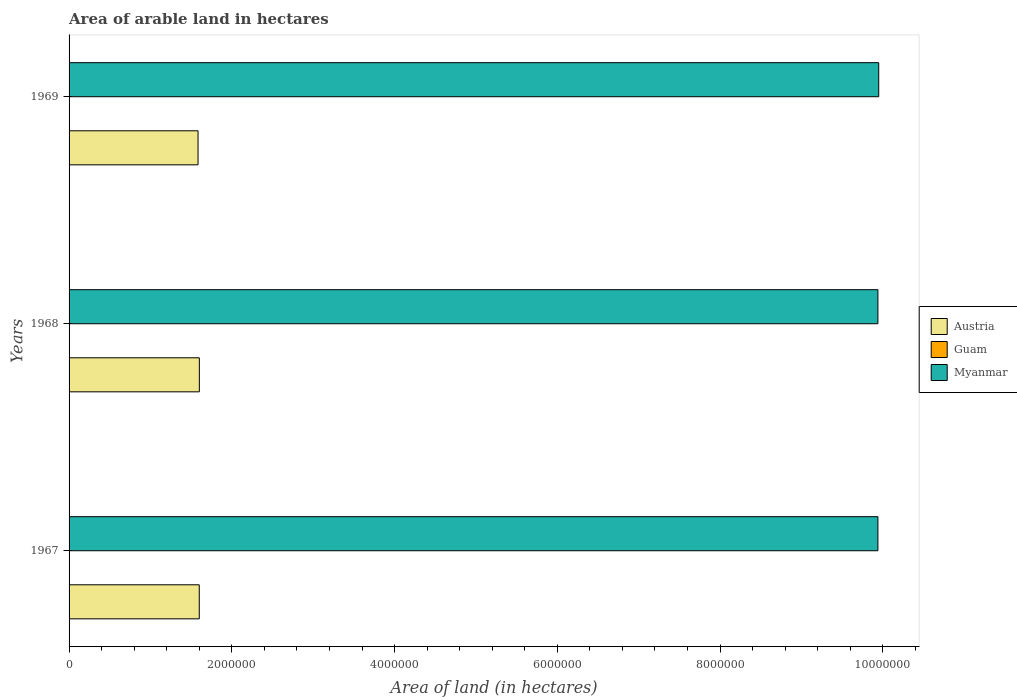How many different coloured bars are there?
Offer a very short reply. 3. How many groups of bars are there?
Give a very brief answer. 3. Are the number of bars per tick equal to the number of legend labels?
Keep it short and to the point. Yes. What is the label of the 3rd group of bars from the top?
Make the answer very short. 1967. What is the total arable land in Myanmar in 1968?
Offer a very short reply. 9.94e+06. Across all years, what is the maximum total arable land in Myanmar?
Offer a terse response. 9.95e+06. Across all years, what is the minimum total arable land in Myanmar?
Ensure brevity in your answer.  9.94e+06. In which year was the total arable land in Austria maximum?
Ensure brevity in your answer.  1968. In which year was the total arable land in Myanmar minimum?
Make the answer very short. 1967. What is the total total arable land in Guam in the graph?
Your answer should be compact. 6000. What is the difference between the total arable land in Guam in 1967 and that in 1968?
Provide a succinct answer. 0. What is the difference between the total arable land in Myanmar in 1967 and the total arable land in Austria in 1969?
Your answer should be very brief. 8.36e+06. What is the average total arable land in Myanmar per year?
Your response must be concise. 9.94e+06. In the year 1967, what is the difference between the total arable land in Myanmar and total arable land in Guam?
Offer a very short reply. 9.94e+06. In how many years, is the total arable land in Myanmar greater than 400000 hectares?
Keep it short and to the point. 3. Is the total arable land in Guam in 1968 less than that in 1969?
Provide a short and direct response. No. What is the difference between the highest and the second highest total arable land in Austria?
Give a very brief answer. 1000. What is the difference between the highest and the lowest total arable land in Myanmar?
Make the answer very short. 10000. In how many years, is the total arable land in Austria greater than the average total arable land in Austria taken over all years?
Give a very brief answer. 2. What does the 2nd bar from the top in 1968 represents?
Your response must be concise. Guam. What does the 1st bar from the bottom in 1967 represents?
Make the answer very short. Austria. Are all the bars in the graph horizontal?
Make the answer very short. Yes. Are the values on the major ticks of X-axis written in scientific E-notation?
Keep it short and to the point. No. How are the legend labels stacked?
Give a very brief answer. Vertical. What is the title of the graph?
Provide a short and direct response. Area of arable land in hectares. What is the label or title of the X-axis?
Your response must be concise. Area of land (in hectares). What is the label or title of the Y-axis?
Ensure brevity in your answer.  Years. What is the Area of land (in hectares) in Austria in 1967?
Ensure brevity in your answer.  1.60e+06. What is the Area of land (in hectares) in Myanmar in 1967?
Offer a very short reply. 9.94e+06. What is the Area of land (in hectares) in Austria in 1968?
Offer a terse response. 1.60e+06. What is the Area of land (in hectares) of Guam in 1968?
Provide a short and direct response. 2000. What is the Area of land (in hectares) in Myanmar in 1968?
Ensure brevity in your answer.  9.94e+06. What is the Area of land (in hectares) of Austria in 1969?
Make the answer very short. 1.58e+06. What is the Area of land (in hectares) of Myanmar in 1969?
Offer a terse response. 9.95e+06. Across all years, what is the maximum Area of land (in hectares) of Austria?
Ensure brevity in your answer.  1.60e+06. Across all years, what is the maximum Area of land (in hectares) in Guam?
Offer a very short reply. 2000. Across all years, what is the maximum Area of land (in hectares) in Myanmar?
Offer a very short reply. 9.95e+06. Across all years, what is the minimum Area of land (in hectares) in Austria?
Offer a very short reply. 1.58e+06. Across all years, what is the minimum Area of land (in hectares) of Myanmar?
Give a very brief answer. 9.94e+06. What is the total Area of land (in hectares) of Austria in the graph?
Offer a terse response. 4.79e+06. What is the total Area of land (in hectares) of Guam in the graph?
Your answer should be very brief. 6000. What is the total Area of land (in hectares) of Myanmar in the graph?
Your response must be concise. 2.98e+07. What is the difference between the Area of land (in hectares) in Austria in 1967 and that in 1968?
Make the answer very short. -1000. What is the difference between the Area of land (in hectares) of Guam in 1967 and that in 1968?
Keep it short and to the point. 0. What is the difference between the Area of land (in hectares) of Myanmar in 1967 and that in 1968?
Ensure brevity in your answer.  0. What is the difference between the Area of land (in hectares) in Austria in 1967 and that in 1969?
Give a very brief answer. 1.50e+04. What is the difference between the Area of land (in hectares) of Guam in 1967 and that in 1969?
Provide a succinct answer. 0. What is the difference between the Area of land (in hectares) of Myanmar in 1967 and that in 1969?
Your answer should be compact. -10000. What is the difference between the Area of land (in hectares) in Austria in 1968 and that in 1969?
Your response must be concise. 1.60e+04. What is the difference between the Area of land (in hectares) of Myanmar in 1968 and that in 1969?
Your answer should be very brief. -10000. What is the difference between the Area of land (in hectares) of Austria in 1967 and the Area of land (in hectares) of Guam in 1968?
Your answer should be very brief. 1.60e+06. What is the difference between the Area of land (in hectares) in Austria in 1967 and the Area of land (in hectares) in Myanmar in 1968?
Give a very brief answer. -8.34e+06. What is the difference between the Area of land (in hectares) in Guam in 1967 and the Area of land (in hectares) in Myanmar in 1968?
Provide a succinct answer. -9.94e+06. What is the difference between the Area of land (in hectares) in Austria in 1967 and the Area of land (in hectares) in Guam in 1969?
Keep it short and to the point. 1.60e+06. What is the difference between the Area of land (in hectares) in Austria in 1967 and the Area of land (in hectares) in Myanmar in 1969?
Your answer should be compact. -8.35e+06. What is the difference between the Area of land (in hectares) in Guam in 1967 and the Area of land (in hectares) in Myanmar in 1969?
Offer a very short reply. -9.95e+06. What is the difference between the Area of land (in hectares) of Austria in 1968 and the Area of land (in hectares) of Guam in 1969?
Keep it short and to the point. 1.60e+06. What is the difference between the Area of land (in hectares) in Austria in 1968 and the Area of land (in hectares) in Myanmar in 1969?
Ensure brevity in your answer.  -8.35e+06. What is the difference between the Area of land (in hectares) in Guam in 1968 and the Area of land (in hectares) in Myanmar in 1969?
Offer a terse response. -9.95e+06. What is the average Area of land (in hectares) of Austria per year?
Provide a short and direct response. 1.60e+06. What is the average Area of land (in hectares) in Myanmar per year?
Ensure brevity in your answer.  9.94e+06. In the year 1967, what is the difference between the Area of land (in hectares) of Austria and Area of land (in hectares) of Guam?
Make the answer very short. 1.60e+06. In the year 1967, what is the difference between the Area of land (in hectares) in Austria and Area of land (in hectares) in Myanmar?
Offer a terse response. -8.34e+06. In the year 1967, what is the difference between the Area of land (in hectares) in Guam and Area of land (in hectares) in Myanmar?
Offer a very short reply. -9.94e+06. In the year 1968, what is the difference between the Area of land (in hectares) in Austria and Area of land (in hectares) in Guam?
Make the answer very short. 1.60e+06. In the year 1968, what is the difference between the Area of land (in hectares) of Austria and Area of land (in hectares) of Myanmar?
Ensure brevity in your answer.  -8.34e+06. In the year 1968, what is the difference between the Area of land (in hectares) in Guam and Area of land (in hectares) in Myanmar?
Offer a very short reply. -9.94e+06. In the year 1969, what is the difference between the Area of land (in hectares) of Austria and Area of land (in hectares) of Guam?
Your response must be concise. 1.58e+06. In the year 1969, what is the difference between the Area of land (in hectares) in Austria and Area of land (in hectares) in Myanmar?
Your answer should be very brief. -8.36e+06. In the year 1969, what is the difference between the Area of land (in hectares) in Guam and Area of land (in hectares) in Myanmar?
Your response must be concise. -9.95e+06. What is the ratio of the Area of land (in hectares) in Guam in 1967 to that in 1968?
Ensure brevity in your answer.  1. What is the ratio of the Area of land (in hectares) in Austria in 1967 to that in 1969?
Your answer should be very brief. 1.01. What is the ratio of the Area of land (in hectares) in Guam in 1967 to that in 1969?
Keep it short and to the point. 1. What is the ratio of the Area of land (in hectares) in Myanmar in 1967 to that in 1969?
Give a very brief answer. 1. What is the ratio of the Area of land (in hectares) in Myanmar in 1968 to that in 1969?
Offer a terse response. 1. What is the difference between the highest and the second highest Area of land (in hectares) of Austria?
Offer a terse response. 1000. What is the difference between the highest and the second highest Area of land (in hectares) of Myanmar?
Your response must be concise. 10000. What is the difference between the highest and the lowest Area of land (in hectares) of Austria?
Your response must be concise. 1.60e+04. What is the difference between the highest and the lowest Area of land (in hectares) in Guam?
Give a very brief answer. 0. What is the difference between the highest and the lowest Area of land (in hectares) of Myanmar?
Give a very brief answer. 10000. 